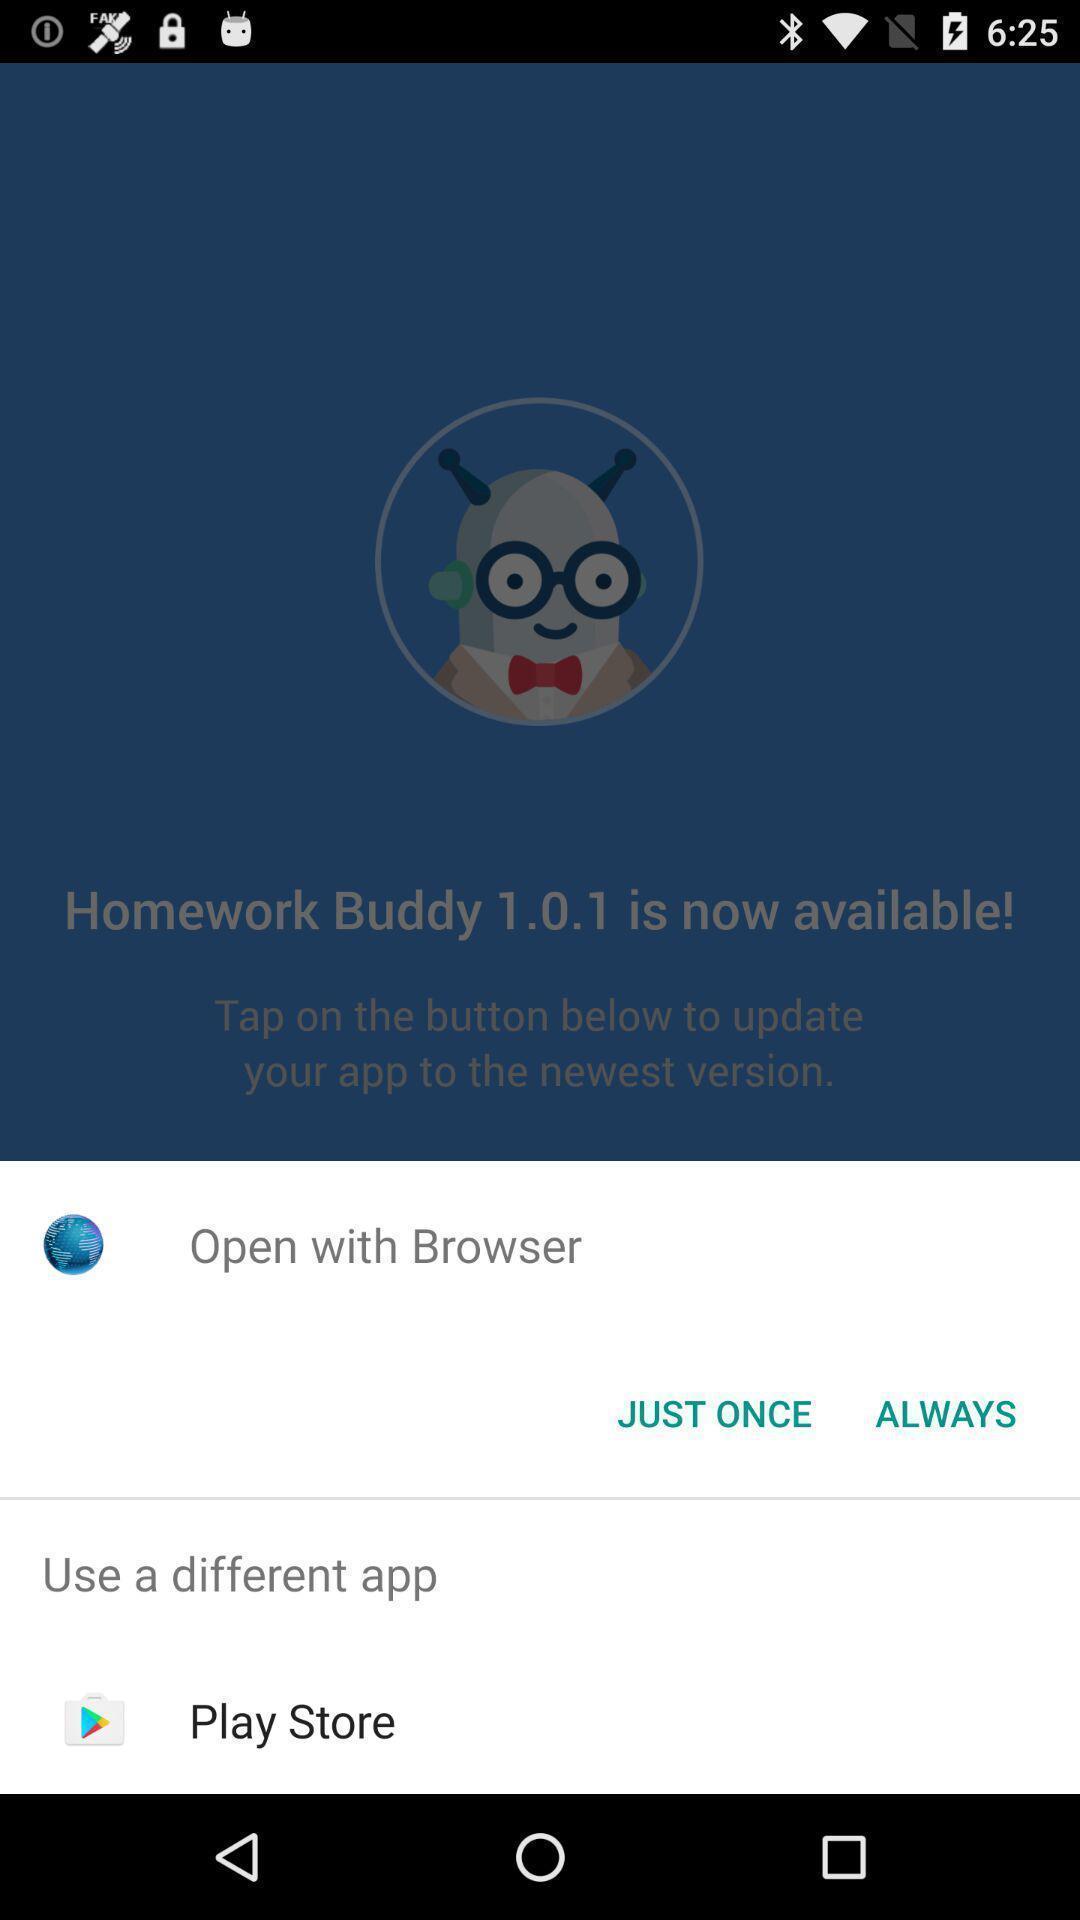Summarize the main components in this picture. Pop-up showing to open the page. 